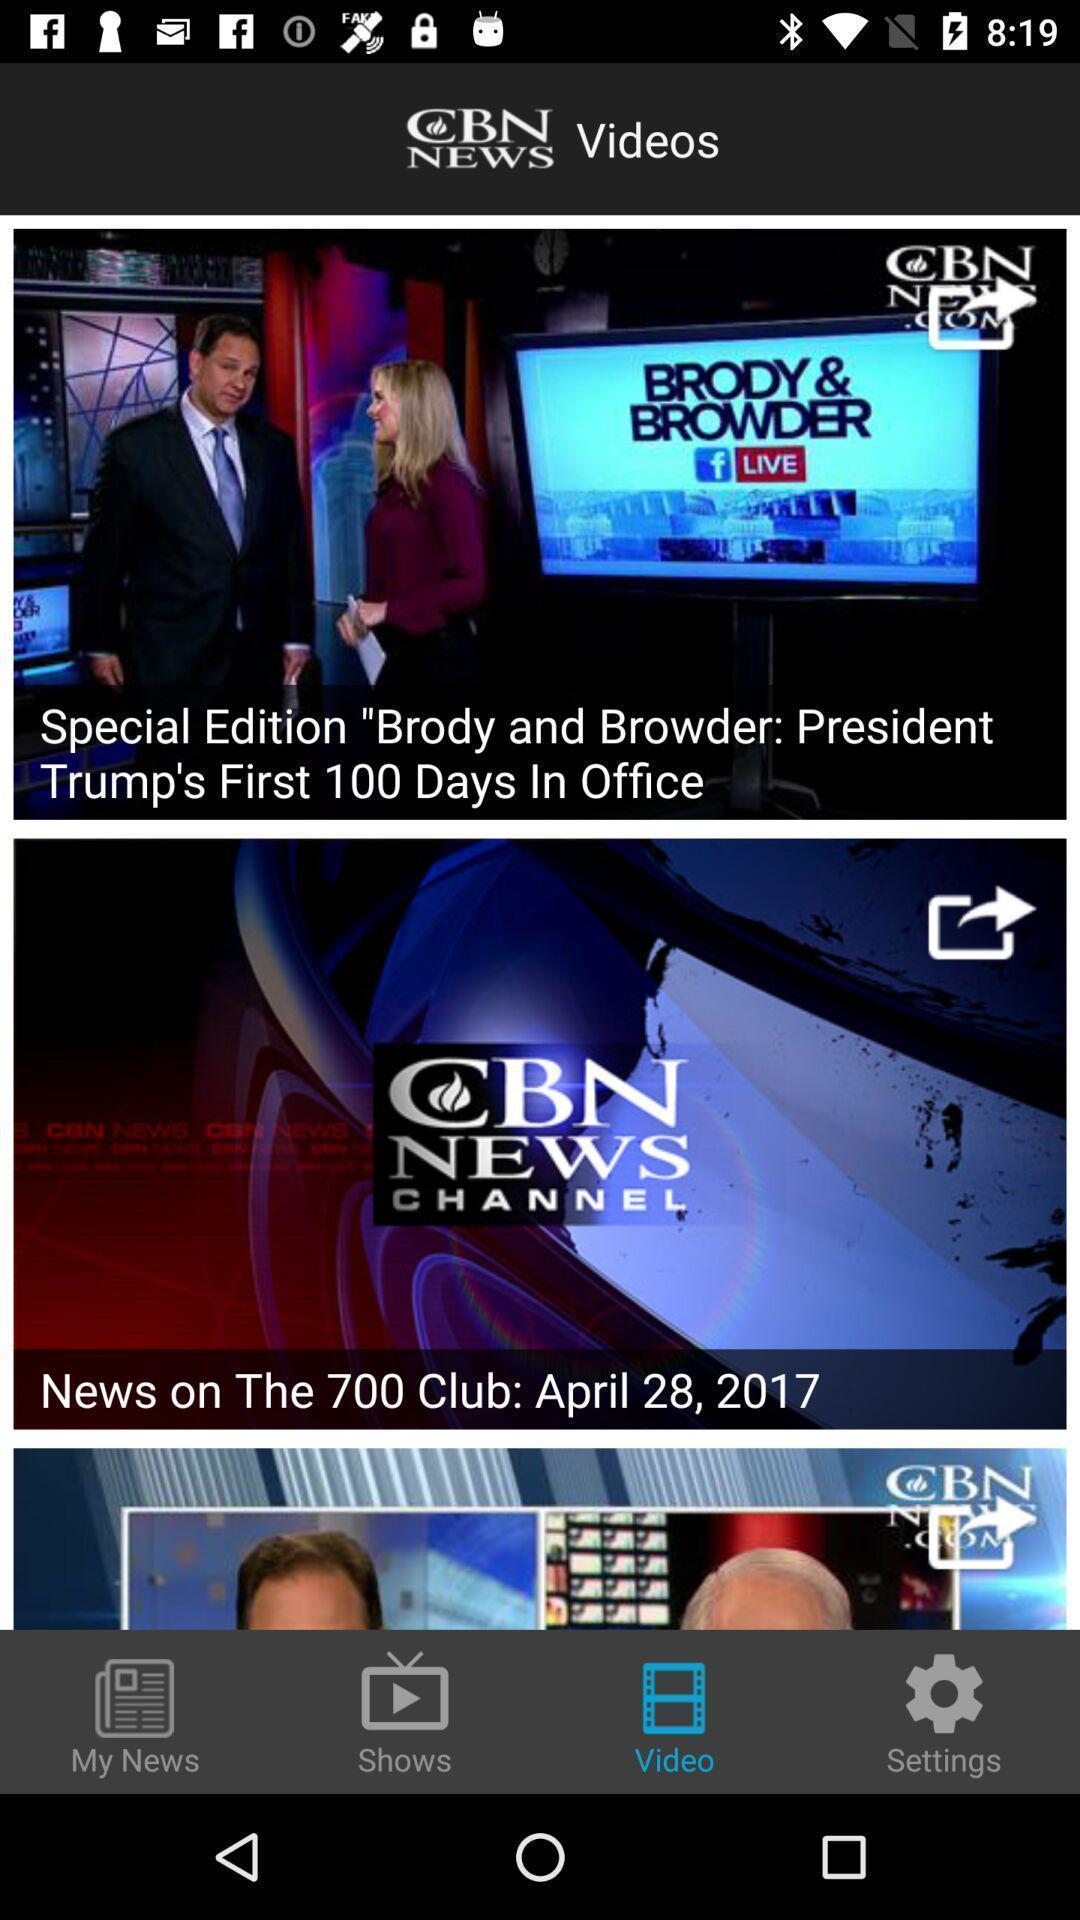Summarize the main components in this picture. Page showing all the latest national news in an application. 